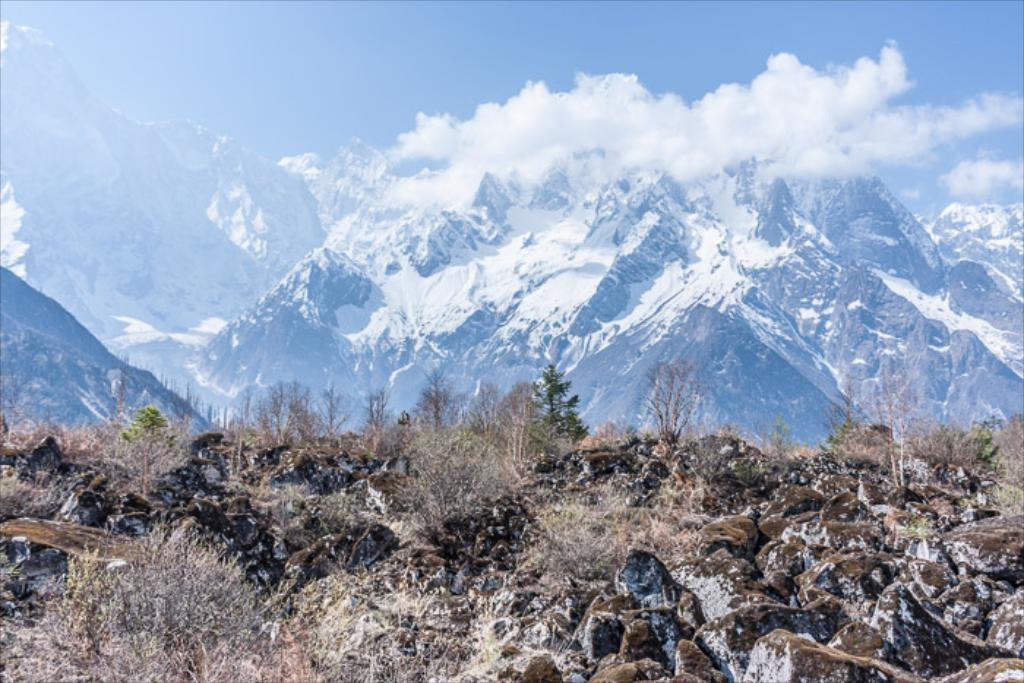What can be seen in the foreground of the image? There are rocks and trees in the foreground of the image. What is located in the background of the image? There are mountains in the background of the image. What is visible at the top of the image? The sky is visible at the top of the image. How many brushes are visible in the image? There are no brushes present in the image. What type of stem can be seen growing from the rocks in the image? There are no stems growing from the rocks in the image. 